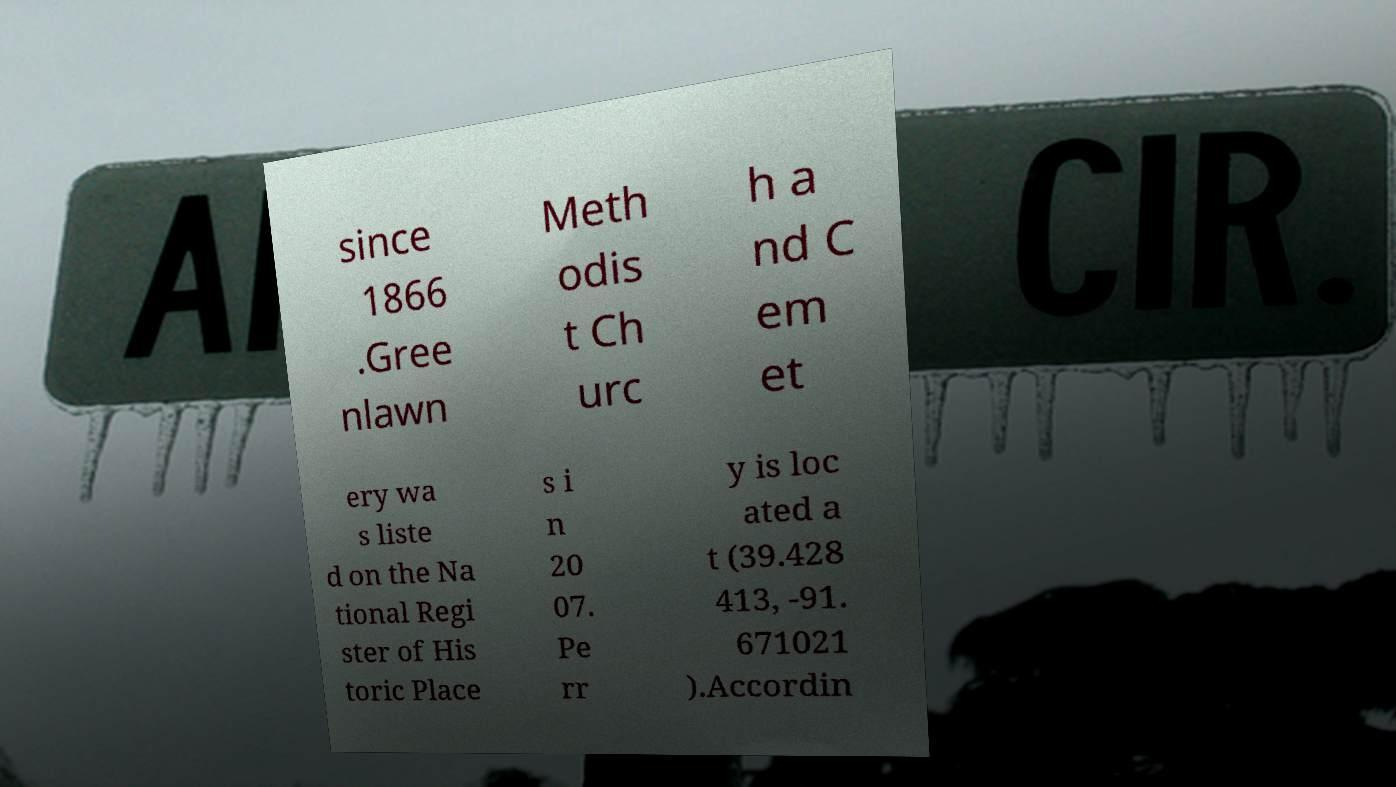What messages or text are displayed in this image? I need them in a readable, typed format. since 1866 .Gree nlawn Meth odis t Ch urc h a nd C em et ery wa s liste d on the Na tional Regi ster of His toric Place s i n 20 07. Pe rr y is loc ated a t (39.428 413, -91. 671021 ).Accordin 